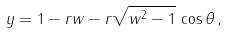<formula> <loc_0><loc_0><loc_500><loc_500>y = 1 - r w - r \sqrt { w ^ { 2 } - 1 } \, \cos \theta \, ,</formula> 